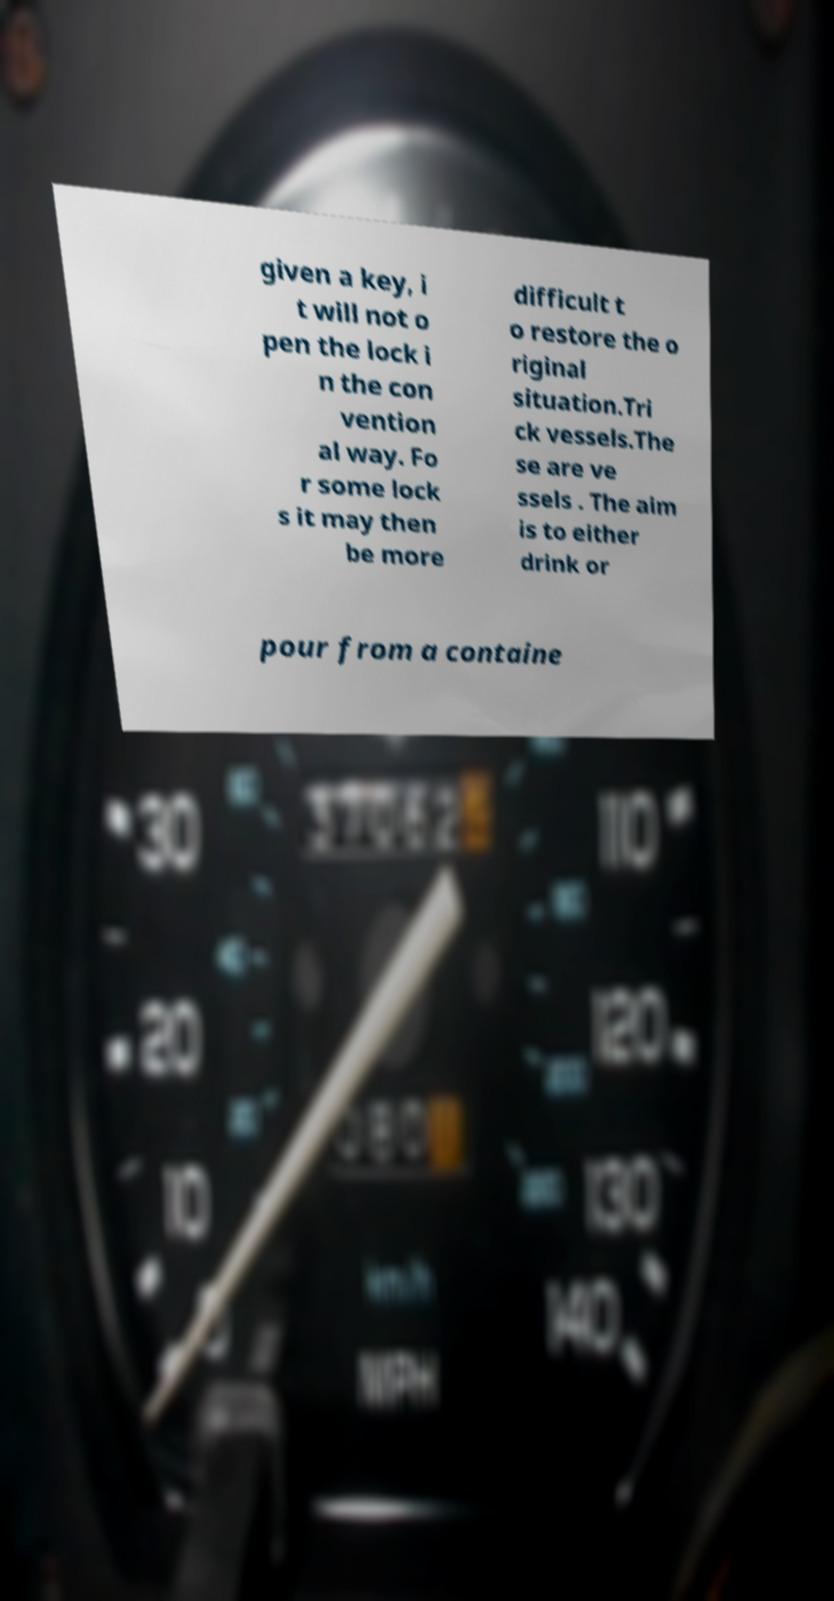For documentation purposes, I need the text within this image transcribed. Could you provide that? given a key, i t will not o pen the lock i n the con vention al way. Fo r some lock s it may then be more difficult t o restore the o riginal situation.Tri ck vessels.The se are ve ssels . The aim is to either drink or pour from a containe 